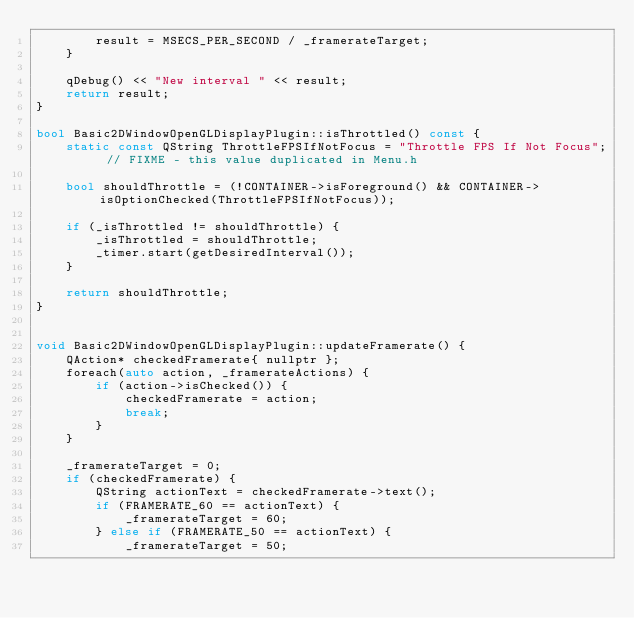Convert code to text. <code><loc_0><loc_0><loc_500><loc_500><_C++_>        result = MSECS_PER_SECOND / _framerateTarget;
    }

    qDebug() << "New interval " << result;
    return result;
}

bool Basic2DWindowOpenGLDisplayPlugin::isThrottled() const {
    static const QString ThrottleFPSIfNotFocus = "Throttle FPS If Not Focus"; // FIXME - this value duplicated in Menu.h

    bool shouldThrottle = (!CONTAINER->isForeground() && CONTAINER->isOptionChecked(ThrottleFPSIfNotFocus));
    
    if (_isThrottled != shouldThrottle) {
        _isThrottled = shouldThrottle;
        _timer.start(getDesiredInterval());
    }
    
    return shouldThrottle;
}


void Basic2DWindowOpenGLDisplayPlugin::updateFramerate() {
    QAction* checkedFramerate{ nullptr };
    foreach(auto action, _framerateActions) {
        if (action->isChecked()) {
            checkedFramerate = action;
            break;
        }
    }

    _framerateTarget = 0;
    if (checkedFramerate) {
        QString actionText = checkedFramerate->text();
        if (FRAMERATE_60 == actionText) {
            _framerateTarget = 60;
        } else if (FRAMERATE_50 == actionText) {
            _framerateTarget = 50;</code> 